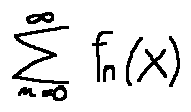Convert formula to latex. <formula><loc_0><loc_0><loc_500><loc_500>\sum \lim i t s _ { n = 0 } ^ { \infty } f _ { n } ( x )</formula> 